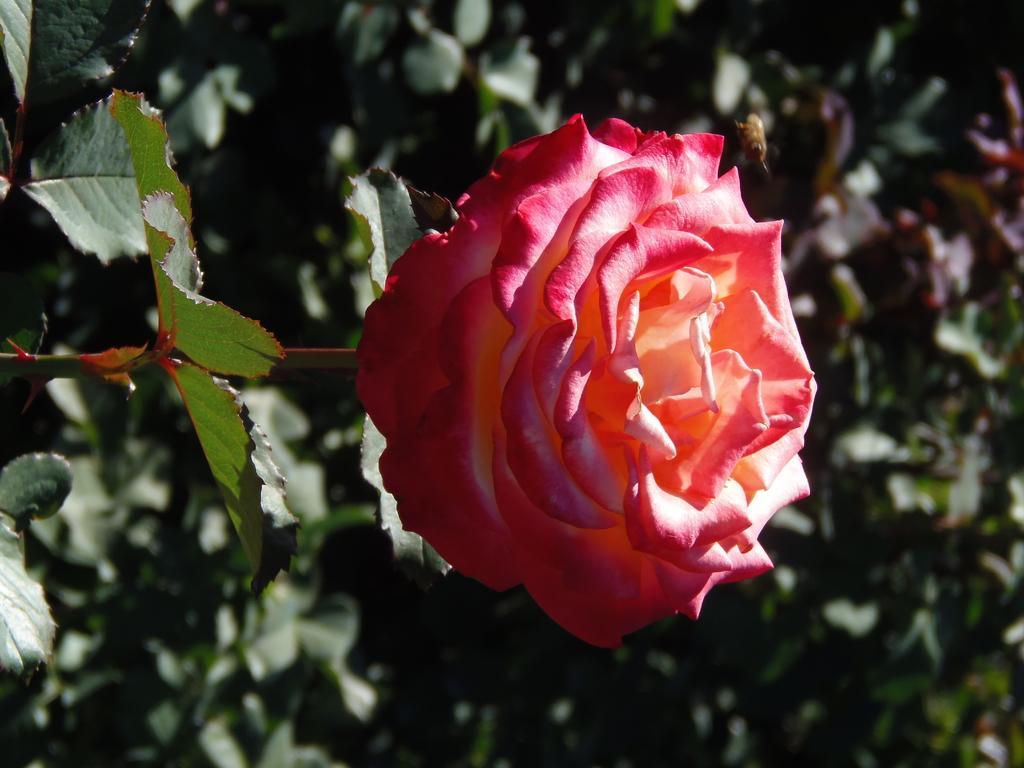Could you give a brief overview of what you see in this image? In this image in the front there is a flower and there are leaves. In the background there are plants. 